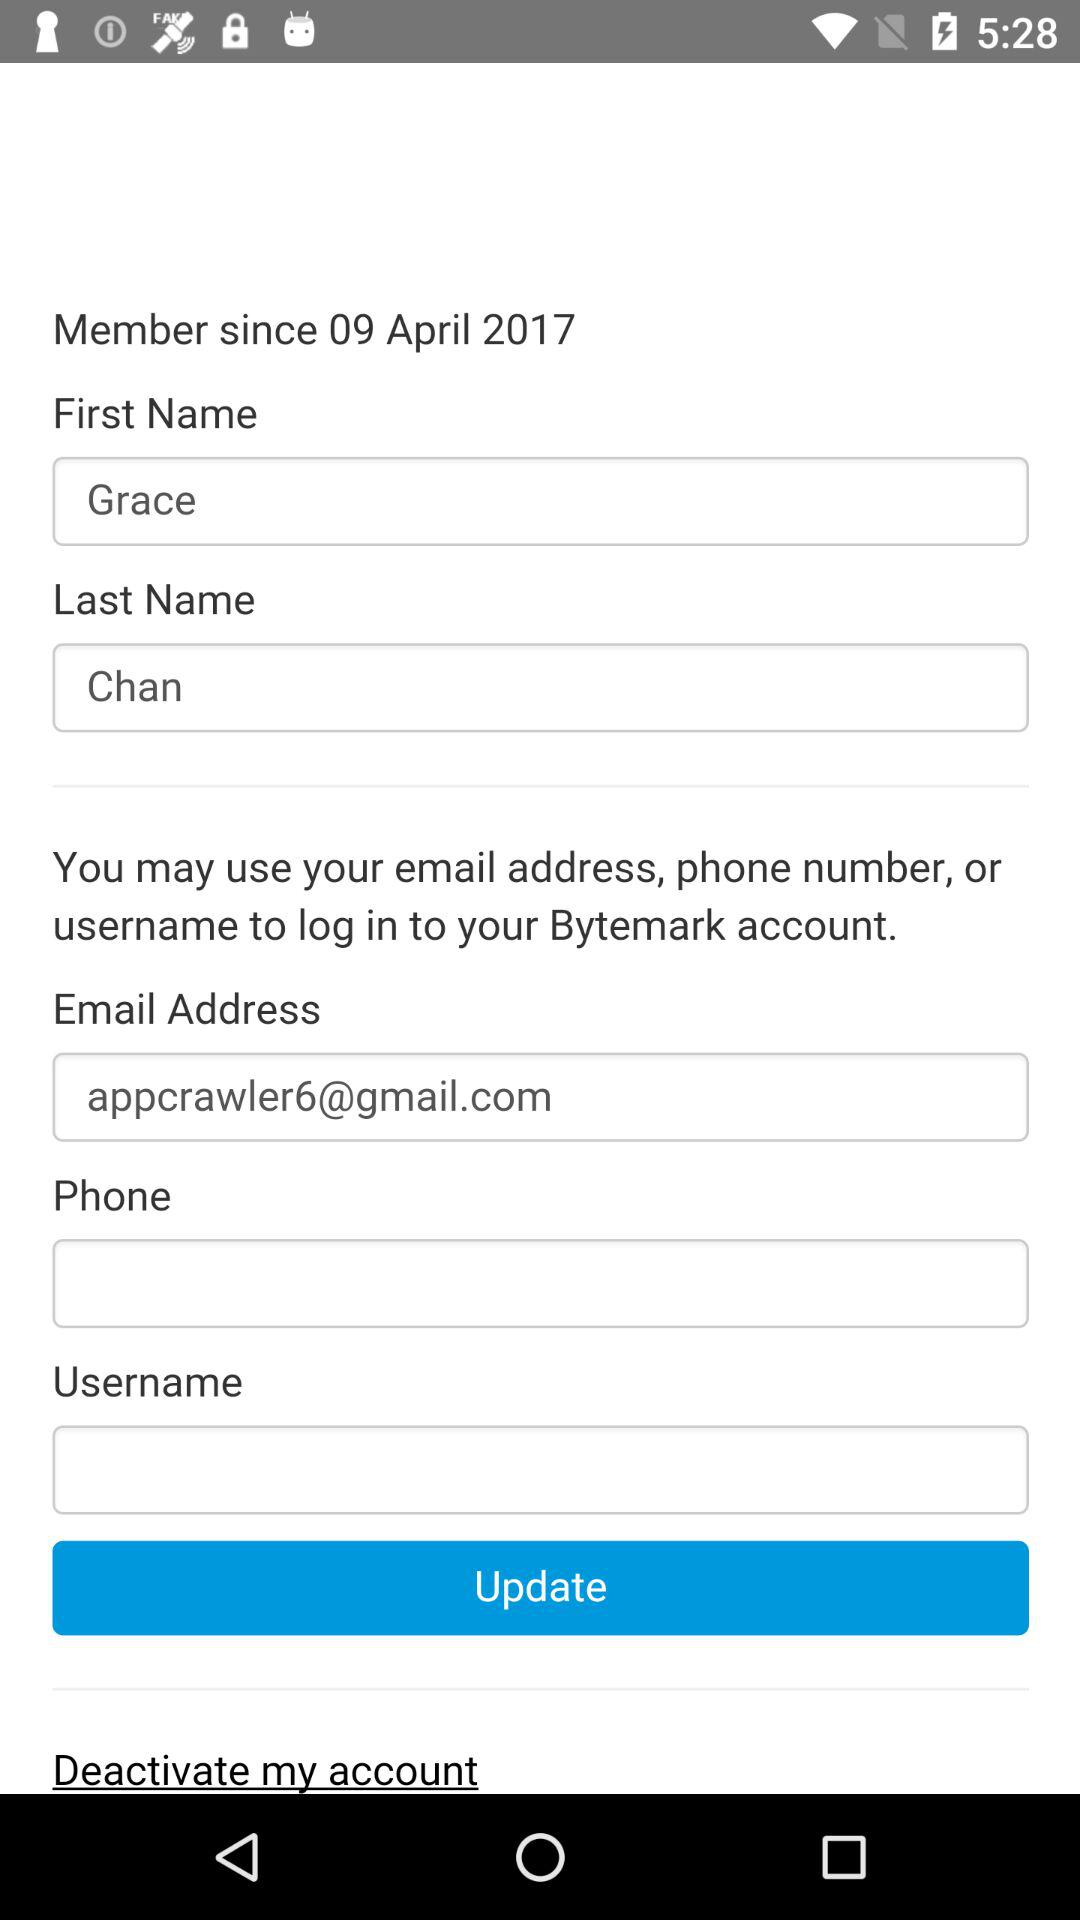What is the email address? The email address is appcrawler6@gmail.com. 